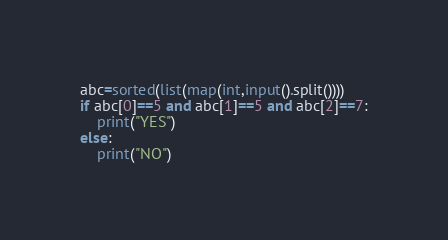Convert code to text. <code><loc_0><loc_0><loc_500><loc_500><_Python_>abc=sorted(list(map(int,input().split())))
if abc[0]==5 and abc[1]==5 and abc[2]==7:
    print("YES")
else:
    print("NO")
</code> 